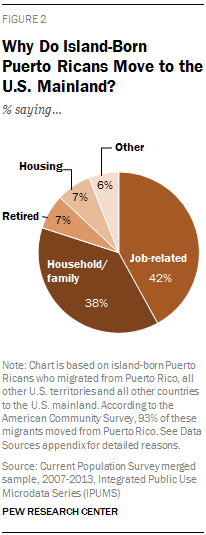Highlight a few significant elements in this photo. The pie chart represents the distribution of Job-related as 0.42% of the total. The sum of Other and Job-related expenses is less than the sum of Housing, Retired, and Household/Family expenses, which means that the latter group of expenses is more significant in terms of overall expenses. 